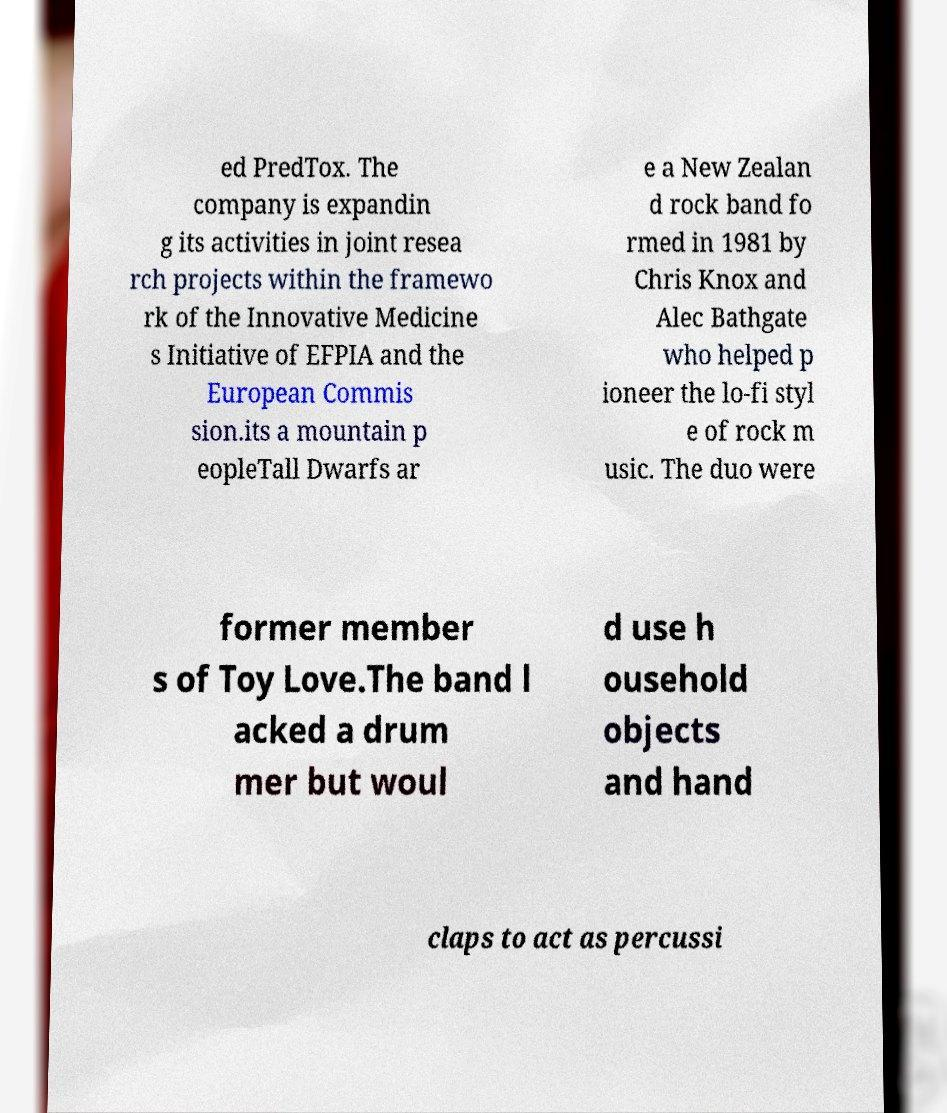Could you extract and type out the text from this image? ed PredTox. The company is expandin g its activities in joint resea rch projects within the framewo rk of the Innovative Medicine s Initiative of EFPIA and the European Commis sion.its a mountain p eopleTall Dwarfs ar e a New Zealan d rock band fo rmed in 1981 by Chris Knox and Alec Bathgate who helped p ioneer the lo-fi styl e of rock m usic. The duo were former member s of Toy Love.The band l acked a drum mer but woul d use h ousehold objects and hand claps to act as percussi 